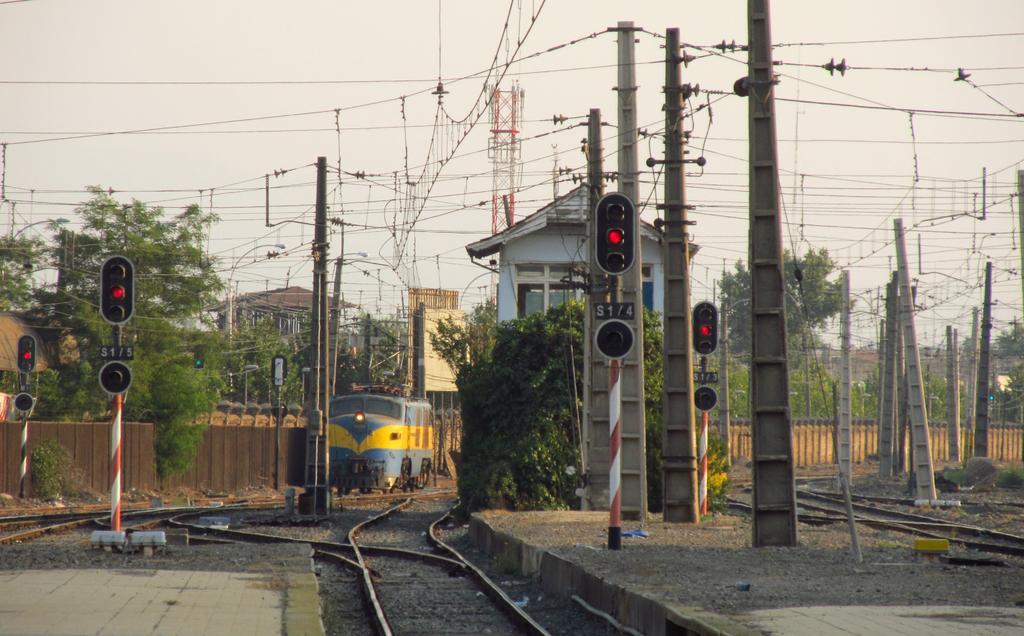Can you describe this image briefly? In the image there is a railway track and there is a train on the track, there are many signal poles and there are plenty of wires attached and interlinked with each other, in between those poles there are some trees and on the left side there is a platform. 